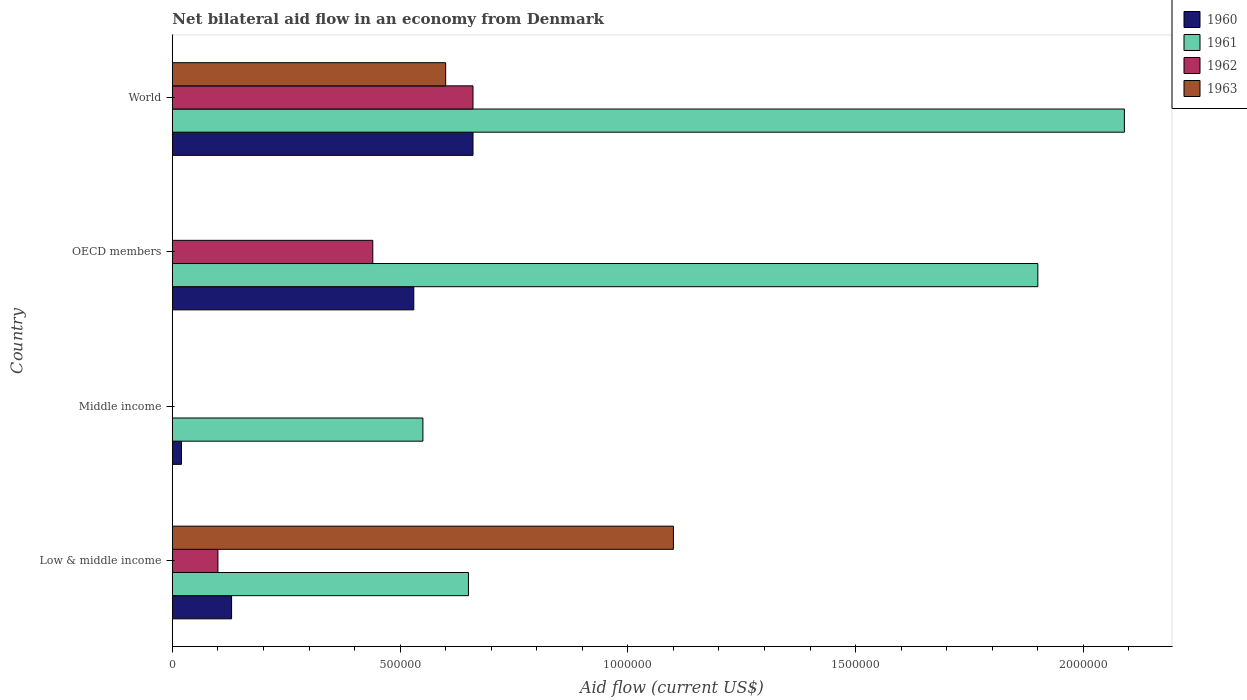How many different coloured bars are there?
Offer a terse response. 4. How many groups of bars are there?
Provide a short and direct response. 4. Are the number of bars per tick equal to the number of legend labels?
Provide a short and direct response. No. What is the label of the 4th group of bars from the top?
Offer a terse response. Low & middle income. Across all countries, what is the maximum net bilateral aid flow in 1961?
Your answer should be very brief. 2.09e+06. What is the total net bilateral aid flow in 1962 in the graph?
Provide a succinct answer. 1.20e+06. What is the difference between the net bilateral aid flow in 1960 in OECD members and that in World?
Keep it short and to the point. -1.30e+05. What is the difference between the net bilateral aid flow in 1961 in OECD members and the net bilateral aid flow in 1963 in World?
Your answer should be compact. 1.30e+06. What is the average net bilateral aid flow in 1962 per country?
Provide a succinct answer. 3.00e+05. In how many countries, is the net bilateral aid flow in 1962 greater than 1300000 US$?
Offer a terse response. 0. What is the ratio of the net bilateral aid flow in 1961 in Low & middle income to that in OECD members?
Your answer should be compact. 0.34. What is the difference between the highest and the lowest net bilateral aid flow in 1961?
Provide a succinct answer. 1.54e+06. In how many countries, is the net bilateral aid flow in 1960 greater than the average net bilateral aid flow in 1960 taken over all countries?
Ensure brevity in your answer.  2. Is the sum of the net bilateral aid flow in 1961 in Low & middle income and World greater than the maximum net bilateral aid flow in 1962 across all countries?
Ensure brevity in your answer.  Yes. Is it the case that in every country, the sum of the net bilateral aid flow in 1961 and net bilateral aid flow in 1962 is greater than the sum of net bilateral aid flow in 1963 and net bilateral aid flow in 1960?
Offer a very short reply. Yes. Is it the case that in every country, the sum of the net bilateral aid flow in 1963 and net bilateral aid flow in 1961 is greater than the net bilateral aid flow in 1960?
Ensure brevity in your answer.  Yes. How many bars are there?
Your answer should be very brief. 13. Are all the bars in the graph horizontal?
Provide a short and direct response. Yes. How many countries are there in the graph?
Offer a very short reply. 4. What is the difference between two consecutive major ticks on the X-axis?
Offer a very short reply. 5.00e+05. Are the values on the major ticks of X-axis written in scientific E-notation?
Offer a terse response. No. Does the graph contain any zero values?
Your response must be concise. Yes. How are the legend labels stacked?
Offer a very short reply. Vertical. What is the title of the graph?
Your answer should be very brief. Net bilateral aid flow in an economy from Denmark. Does "2010" appear as one of the legend labels in the graph?
Ensure brevity in your answer.  No. What is the label or title of the X-axis?
Ensure brevity in your answer.  Aid flow (current US$). What is the label or title of the Y-axis?
Your answer should be compact. Country. What is the Aid flow (current US$) of 1960 in Low & middle income?
Offer a terse response. 1.30e+05. What is the Aid flow (current US$) in 1961 in Low & middle income?
Provide a succinct answer. 6.50e+05. What is the Aid flow (current US$) in 1963 in Low & middle income?
Give a very brief answer. 1.10e+06. What is the Aid flow (current US$) of 1962 in Middle income?
Your answer should be compact. 0. What is the Aid flow (current US$) of 1963 in Middle income?
Offer a very short reply. 0. What is the Aid flow (current US$) of 1960 in OECD members?
Your answer should be very brief. 5.30e+05. What is the Aid flow (current US$) in 1961 in OECD members?
Your response must be concise. 1.90e+06. What is the Aid flow (current US$) of 1963 in OECD members?
Your response must be concise. 0. What is the Aid flow (current US$) of 1961 in World?
Ensure brevity in your answer.  2.09e+06. What is the Aid flow (current US$) in 1962 in World?
Keep it short and to the point. 6.60e+05. Across all countries, what is the maximum Aid flow (current US$) in 1960?
Make the answer very short. 6.60e+05. Across all countries, what is the maximum Aid flow (current US$) of 1961?
Keep it short and to the point. 2.09e+06. Across all countries, what is the maximum Aid flow (current US$) in 1963?
Provide a short and direct response. 1.10e+06. Across all countries, what is the minimum Aid flow (current US$) in 1960?
Provide a succinct answer. 2.00e+04. What is the total Aid flow (current US$) of 1960 in the graph?
Give a very brief answer. 1.34e+06. What is the total Aid flow (current US$) in 1961 in the graph?
Keep it short and to the point. 5.19e+06. What is the total Aid flow (current US$) in 1962 in the graph?
Ensure brevity in your answer.  1.20e+06. What is the total Aid flow (current US$) of 1963 in the graph?
Ensure brevity in your answer.  1.70e+06. What is the difference between the Aid flow (current US$) in 1961 in Low & middle income and that in Middle income?
Ensure brevity in your answer.  1.00e+05. What is the difference between the Aid flow (current US$) of 1960 in Low & middle income and that in OECD members?
Provide a succinct answer. -4.00e+05. What is the difference between the Aid flow (current US$) in 1961 in Low & middle income and that in OECD members?
Give a very brief answer. -1.25e+06. What is the difference between the Aid flow (current US$) in 1962 in Low & middle income and that in OECD members?
Offer a terse response. -3.40e+05. What is the difference between the Aid flow (current US$) in 1960 in Low & middle income and that in World?
Provide a succinct answer. -5.30e+05. What is the difference between the Aid flow (current US$) of 1961 in Low & middle income and that in World?
Your answer should be very brief. -1.44e+06. What is the difference between the Aid flow (current US$) in 1962 in Low & middle income and that in World?
Your answer should be very brief. -5.60e+05. What is the difference between the Aid flow (current US$) of 1960 in Middle income and that in OECD members?
Ensure brevity in your answer.  -5.10e+05. What is the difference between the Aid flow (current US$) of 1961 in Middle income and that in OECD members?
Provide a short and direct response. -1.35e+06. What is the difference between the Aid flow (current US$) in 1960 in Middle income and that in World?
Offer a very short reply. -6.40e+05. What is the difference between the Aid flow (current US$) in 1961 in Middle income and that in World?
Offer a terse response. -1.54e+06. What is the difference between the Aid flow (current US$) in 1960 in OECD members and that in World?
Your answer should be very brief. -1.30e+05. What is the difference between the Aid flow (current US$) of 1962 in OECD members and that in World?
Keep it short and to the point. -2.20e+05. What is the difference between the Aid flow (current US$) in 1960 in Low & middle income and the Aid flow (current US$) in 1961 in Middle income?
Make the answer very short. -4.20e+05. What is the difference between the Aid flow (current US$) in 1960 in Low & middle income and the Aid flow (current US$) in 1961 in OECD members?
Provide a short and direct response. -1.77e+06. What is the difference between the Aid flow (current US$) in 1960 in Low & middle income and the Aid flow (current US$) in 1962 in OECD members?
Your answer should be very brief. -3.10e+05. What is the difference between the Aid flow (current US$) of 1961 in Low & middle income and the Aid flow (current US$) of 1962 in OECD members?
Your answer should be very brief. 2.10e+05. What is the difference between the Aid flow (current US$) in 1960 in Low & middle income and the Aid flow (current US$) in 1961 in World?
Provide a short and direct response. -1.96e+06. What is the difference between the Aid flow (current US$) of 1960 in Low & middle income and the Aid flow (current US$) of 1962 in World?
Your response must be concise. -5.30e+05. What is the difference between the Aid flow (current US$) in 1960 in Low & middle income and the Aid flow (current US$) in 1963 in World?
Offer a very short reply. -4.70e+05. What is the difference between the Aid flow (current US$) of 1961 in Low & middle income and the Aid flow (current US$) of 1962 in World?
Offer a terse response. -10000. What is the difference between the Aid flow (current US$) of 1961 in Low & middle income and the Aid flow (current US$) of 1963 in World?
Keep it short and to the point. 5.00e+04. What is the difference between the Aid flow (current US$) in 1962 in Low & middle income and the Aid flow (current US$) in 1963 in World?
Give a very brief answer. -5.00e+05. What is the difference between the Aid flow (current US$) in 1960 in Middle income and the Aid flow (current US$) in 1961 in OECD members?
Provide a succinct answer. -1.88e+06. What is the difference between the Aid flow (current US$) in 1960 in Middle income and the Aid flow (current US$) in 1962 in OECD members?
Ensure brevity in your answer.  -4.20e+05. What is the difference between the Aid flow (current US$) in 1961 in Middle income and the Aid flow (current US$) in 1962 in OECD members?
Your answer should be very brief. 1.10e+05. What is the difference between the Aid flow (current US$) of 1960 in Middle income and the Aid flow (current US$) of 1961 in World?
Give a very brief answer. -2.07e+06. What is the difference between the Aid flow (current US$) of 1960 in Middle income and the Aid flow (current US$) of 1962 in World?
Your answer should be very brief. -6.40e+05. What is the difference between the Aid flow (current US$) in 1960 in Middle income and the Aid flow (current US$) in 1963 in World?
Your answer should be very brief. -5.80e+05. What is the difference between the Aid flow (current US$) of 1960 in OECD members and the Aid flow (current US$) of 1961 in World?
Give a very brief answer. -1.56e+06. What is the difference between the Aid flow (current US$) in 1960 in OECD members and the Aid flow (current US$) in 1963 in World?
Offer a very short reply. -7.00e+04. What is the difference between the Aid flow (current US$) of 1961 in OECD members and the Aid flow (current US$) of 1962 in World?
Keep it short and to the point. 1.24e+06. What is the difference between the Aid flow (current US$) in 1961 in OECD members and the Aid flow (current US$) in 1963 in World?
Provide a succinct answer. 1.30e+06. What is the average Aid flow (current US$) in 1960 per country?
Ensure brevity in your answer.  3.35e+05. What is the average Aid flow (current US$) of 1961 per country?
Your answer should be very brief. 1.30e+06. What is the average Aid flow (current US$) of 1963 per country?
Offer a very short reply. 4.25e+05. What is the difference between the Aid flow (current US$) in 1960 and Aid flow (current US$) in 1961 in Low & middle income?
Your response must be concise. -5.20e+05. What is the difference between the Aid flow (current US$) of 1960 and Aid flow (current US$) of 1963 in Low & middle income?
Make the answer very short. -9.70e+05. What is the difference between the Aid flow (current US$) in 1961 and Aid flow (current US$) in 1962 in Low & middle income?
Ensure brevity in your answer.  5.50e+05. What is the difference between the Aid flow (current US$) of 1961 and Aid flow (current US$) of 1963 in Low & middle income?
Your answer should be compact. -4.50e+05. What is the difference between the Aid flow (current US$) of 1962 and Aid flow (current US$) of 1963 in Low & middle income?
Give a very brief answer. -1.00e+06. What is the difference between the Aid flow (current US$) of 1960 and Aid flow (current US$) of 1961 in Middle income?
Offer a terse response. -5.30e+05. What is the difference between the Aid flow (current US$) in 1960 and Aid flow (current US$) in 1961 in OECD members?
Keep it short and to the point. -1.37e+06. What is the difference between the Aid flow (current US$) in 1961 and Aid flow (current US$) in 1962 in OECD members?
Provide a succinct answer. 1.46e+06. What is the difference between the Aid flow (current US$) of 1960 and Aid flow (current US$) of 1961 in World?
Your answer should be very brief. -1.43e+06. What is the difference between the Aid flow (current US$) in 1960 and Aid flow (current US$) in 1963 in World?
Give a very brief answer. 6.00e+04. What is the difference between the Aid flow (current US$) of 1961 and Aid flow (current US$) of 1962 in World?
Ensure brevity in your answer.  1.43e+06. What is the difference between the Aid flow (current US$) in 1961 and Aid flow (current US$) in 1963 in World?
Your answer should be very brief. 1.49e+06. What is the difference between the Aid flow (current US$) in 1962 and Aid flow (current US$) in 1963 in World?
Give a very brief answer. 6.00e+04. What is the ratio of the Aid flow (current US$) in 1960 in Low & middle income to that in Middle income?
Provide a succinct answer. 6.5. What is the ratio of the Aid flow (current US$) in 1961 in Low & middle income to that in Middle income?
Offer a very short reply. 1.18. What is the ratio of the Aid flow (current US$) in 1960 in Low & middle income to that in OECD members?
Offer a very short reply. 0.25. What is the ratio of the Aid flow (current US$) in 1961 in Low & middle income to that in OECD members?
Offer a terse response. 0.34. What is the ratio of the Aid flow (current US$) of 1962 in Low & middle income to that in OECD members?
Give a very brief answer. 0.23. What is the ratio of the Aid flow (current US$) in 1960 in Low & middle income to that in World?
Provide a short and direct response. 0.2. What is the ratio of the Aid flow (current US$) of 1961 in Low & middle income to that in World?
Keep it short and to the point. 0.31. What is the ratio of the Aid flow (current US$) in 1962 in Low & middle income to that in World?
Keep it short and to the point. 0.15. What is the ratio of the Aid flow (current US$) in 1963 in Low & middle income to that in World?
Your answer should be compact. 1.83. What is the ratio of the Aid flow (current US$) of 1960 in Middle income to that in OECD members?
Give a very brief answer. 0.04. What is the ratio of the Aid flow (current US$) in 1961 in Middle income to that in OECD members?
Make the answer very short. 0.29. What is the ratio of the Aid flow (current US$) of 1960 in Middle income to that in World?
Your answer should be compact. 0.03. What is the ratio of the Aid flow (current US$) in 1961 in Middle income to that in World?
Provide a short and direct response. 0.26. What is the ratio of the Aid flow (current US$) of 1960 in OECD members to that in World?
Make the answer very short. 0.8. What is the ratio of the Aid flow (current US$) in 1961 in OECD members to that in World?
Make the answer very short. 0.91. What is the ratio of the Aid flow (current US$) in 1962 in OECD members to that in World?
Your response must be concise. 0.67. What is the difference between the highest and the lowest Aid flow (current US$) in 1960?
Provide a succinct answer. 6.40e+05. What is the difference between the highest and the lowest Aid flow (current US$) in 1961?
Make the answer very short. 1.54e+06. What is the difference between the highest and the lowest Aid flow (current US$) of 1962?
Provide a succinct answer. 6.60e+05. What is the difference between the highest and the lowest Aid flow (current US$) of 1963?
Your answer should be very brief. 1.10e+06. 